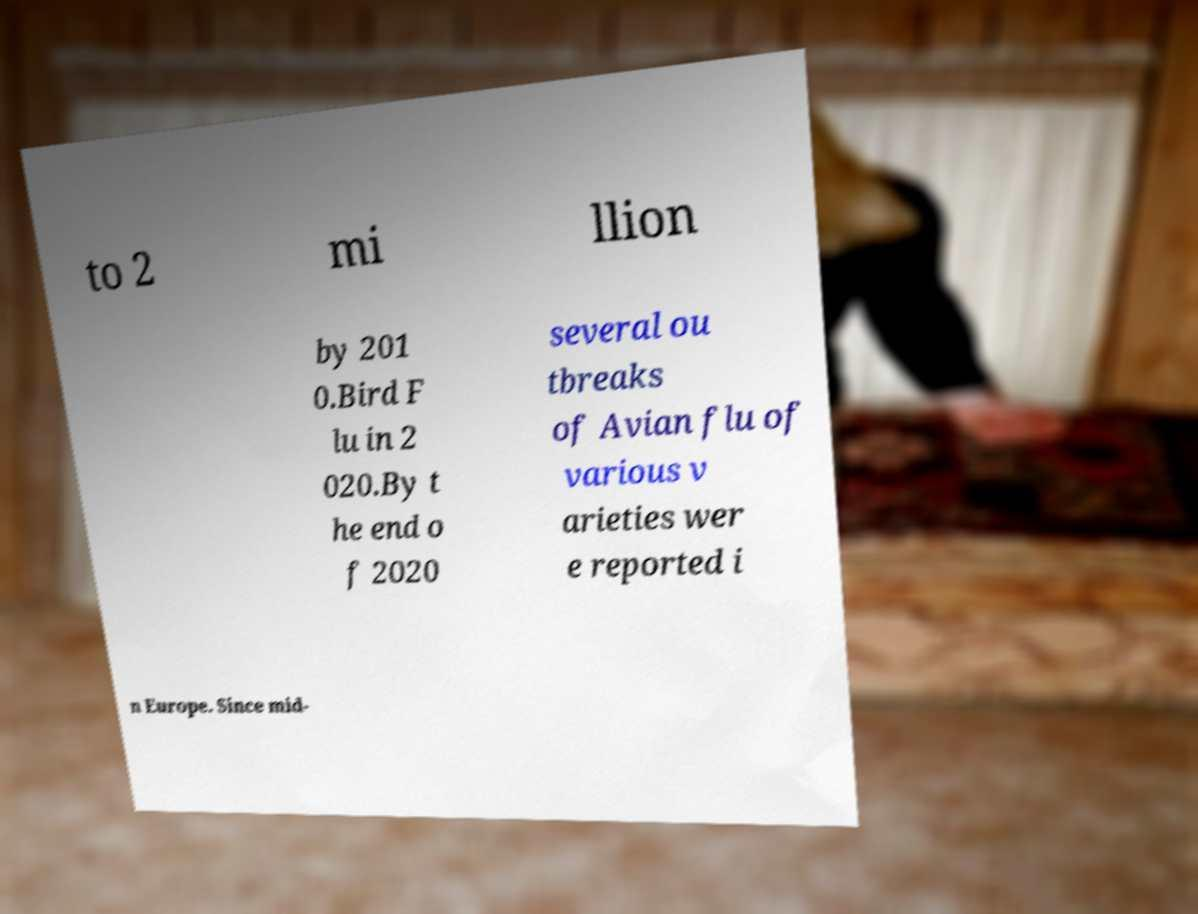There's text embedded in this image that I need extracted. Can you transcribe it verbatim? to 2 mi llion by 201 0.Bird F lu in 2 020.By t he end o f 2020 several ou tbreaks of Avian flu of various v arieties wer e reported i n Europe. Since mid- 